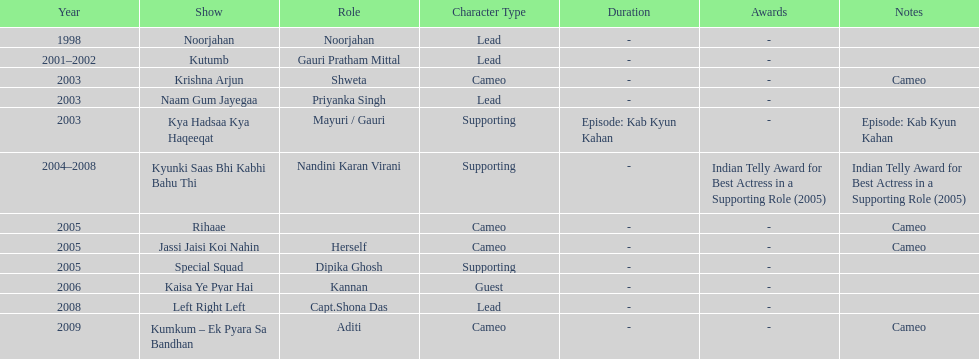Besides rihaae, in what other show did gauri tejwani cameo in 2005? Jassi Jaisi Koi Nahin. 